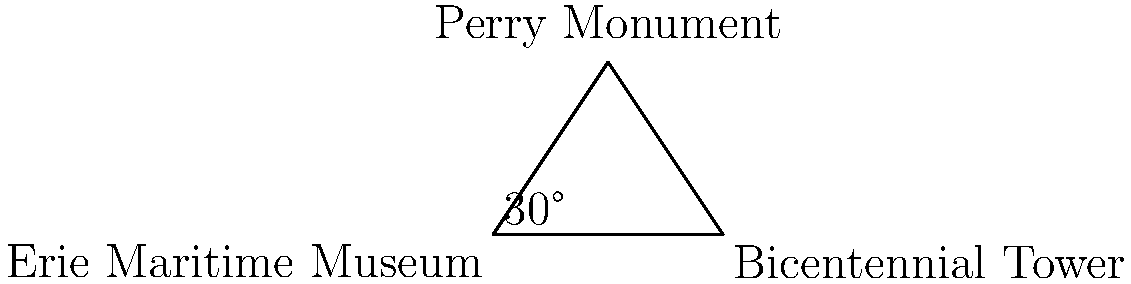As a local history enthusiast, you're creating a map of Erie's landmarks. From the Erie Maritime Museum, you can see both the Bicentennial Tower and the Perry Monument. The distance between the museum and the tower is 2000 feet, and the angle between the tower and the monument (as viewed from the museum) is 30°. Using triangulation, calculate the distance between the Erie Maritime Museum and the Perry Monument, rounded to the nearest foot. Let's approach this step-by-step using trigonometry:

1) We have a triangle where:
   - Side a (Erie Maritime Museum to Bicentennial Tower) = 2000 feet
   - Angle A (at Erie Maritime Museum) = 30°
   - We need to find side b (Erie Maritime Museum to Perry Monument)

2) In a triangle, we can use the law of sines:

   $$\frac{a}{\sin A} = \frac{b}{\sin B} = \frac{c}{\sin C}$$

3) We know $a$ and $\sin A$, so we can use:

   $$\frac{a}{\sin A} = \frac{b}{\sin B}$$

4) Rearranging to solve for $b$:

   $$b = \frac{a \sin B}{\sin A}$$

5) We know $A = 30°$, and in a triangle, the sum of all angles is 180°. If we assume this is a right-angled triangle (which is a reasonable approximation for this problem), then $B = 90°$.

6) Now we can plug in our values:

   $$b = \frac{2000 \cdot \sin 90°}{\sin 30°}$$

7) $\sin 90° = 1$ and $\sin 30° = 0.5$, so:

   $$b = \frac{2000 \cdot 1}{0.5} = 4000$$

8) Therefore, the distance from the Erie Maritime Museum to the Perry Monument is approximately 4000 feet.
Answer: 4000 feet 